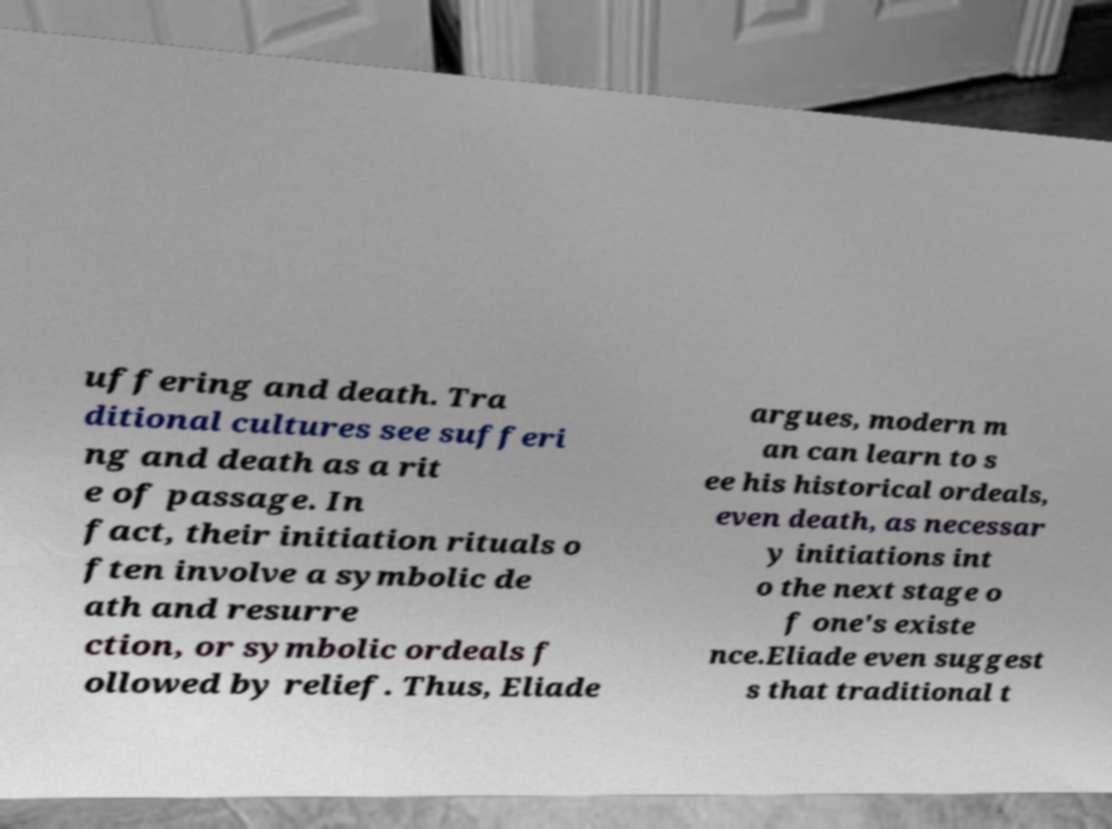Please identify and transcribe the text found in this image. uffering and death. Tra ditional cultures see sufferi ng and death as a rit e of passage. In fact, their initiation rituals o ften involve a symbolic de ath and resurre ction, or symbolic ordeals f ollowed by relief. Thus, Eliade argues, modern m an can learn to s ee his historical ordeals, even death, as necessar y initiations int o the next stage o f one's existe nce.Eliade even suggest s that traditional t 